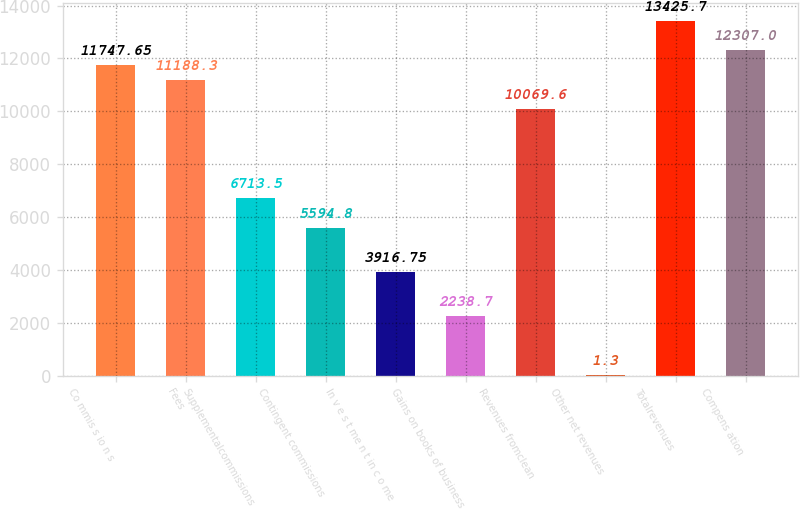Convert chart to OTSL. <chart><loc_0><loc_0><loc_500><loc_500><bar_chart><fcel>Co mmis s io n s<fcel>Fees<fcel>Supplementalcommissions<fcel>Contingent commissions<fcel>In v e s t me n t in c o me<fcel>Gains on books of business<fcel>Revenues fromclean<fcel>Other net revenues<fcel>Totalrevenues<fcel>Compens ation<nl><fcel>11747.6<fcel>11188.3<fcel>6713.5<fcel>5594.8<fcel>3916.75<fcel>2238.7<fcel>10069.6<fcel>1.3<fcel>13425.7<fcel>12307<nl></chart> 